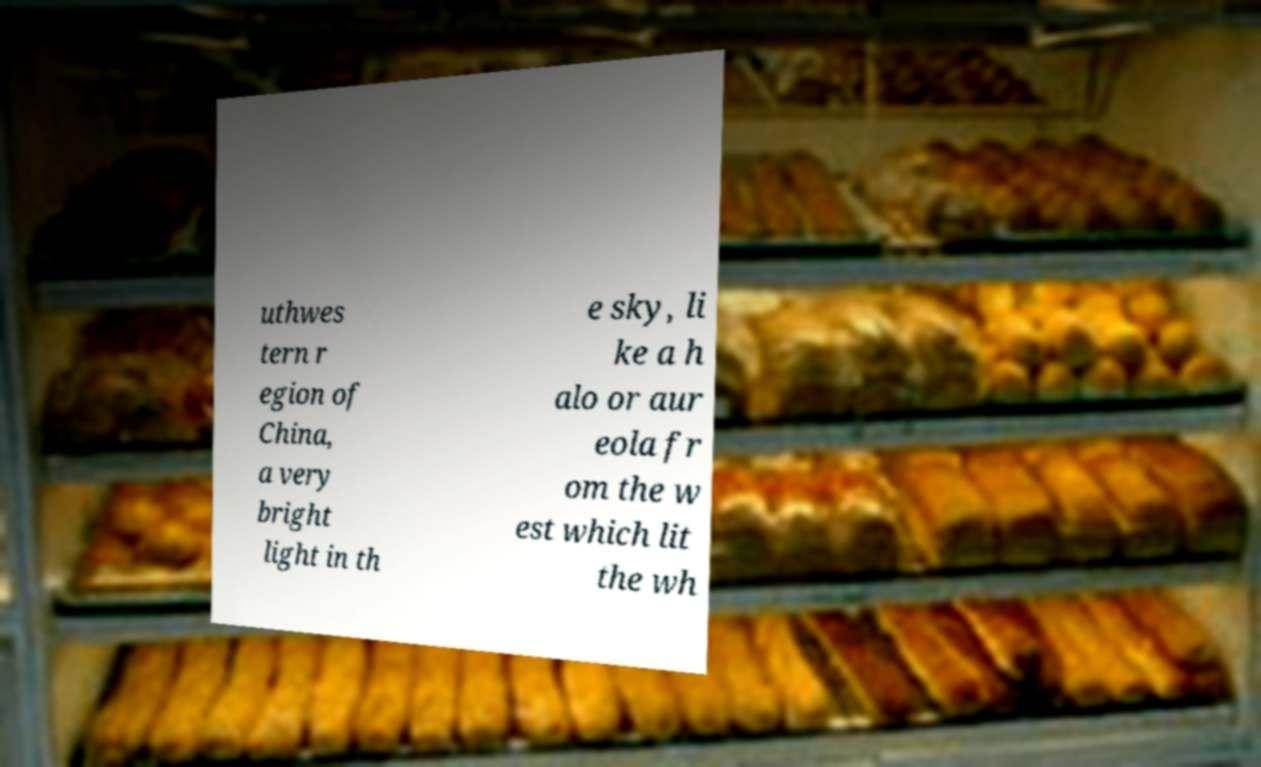Can you accurately transcribe the text from the provided image for me? uthwes tern r egion of China, a very bright light in th e sky, li ke a h alo or aur eola fr om the w est which lit the wh 